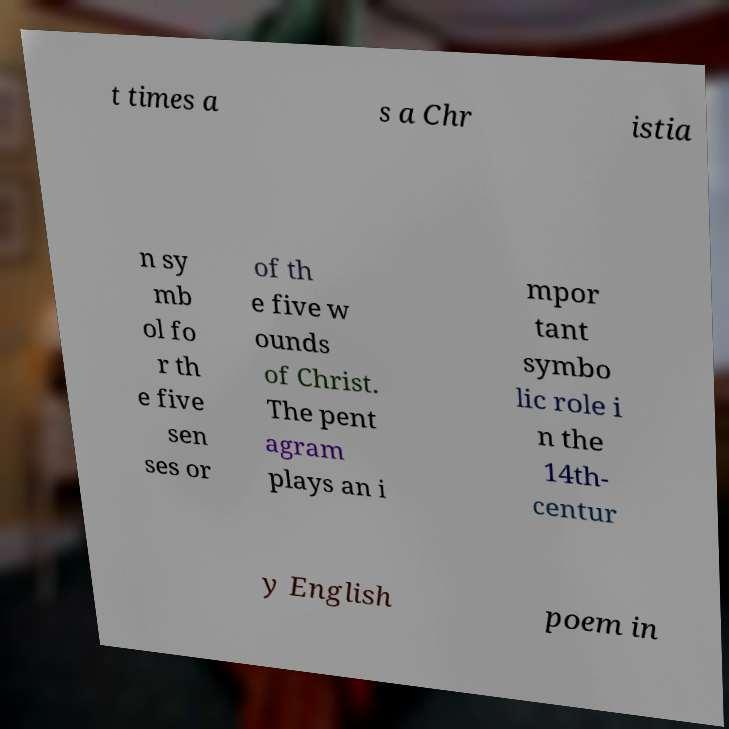For documentation purposes, I need the text within this image transcribed. Could you provide that? t times a s a Chr istia n sy mb ol fo r th e five sen ses or of th e five w ounds of Christ. The pent agram plays an i mpor tant symbo lic role i n the 14th- centur y English poem in 